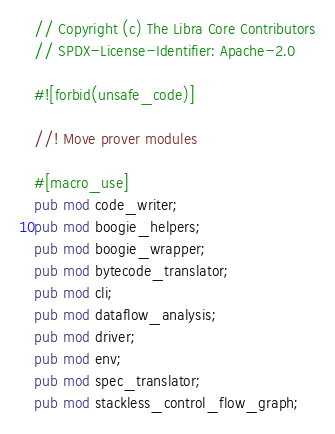<code> <loc_0><loc_0><loc_500><loc_500><_Rust_>// Copyright (c) The Libra Core Contributors
// SPDX-License-Identifier: Apache-2.0

#![forbid(unsafe_code)]

//! Move prover modules

#[macro_use]
pub mod code_writer;
pub mod boogie_helpers;
pub mod boogie_wrapper;
pub mod bytecode_translator;
pub mod cli;
pub mod dataflow_analysis;
pub mod driver;
pub mod env;
pub mod spec_translator;
pub mod stackless_control_flow_graph;
</code> 